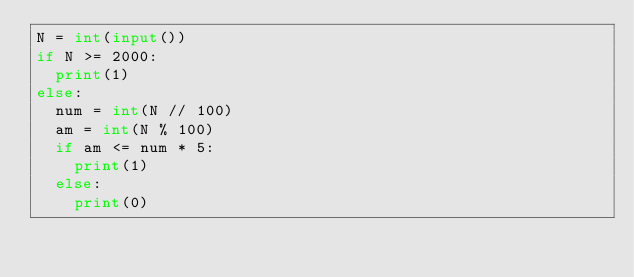Convert code to text. <code><loc_0><loc_0><loc_500><loc_500><_Python_>N = int(input())
if N >= 2000:
	print(1)
else:
	num = int(N // 100)
	am = int(N % 100)
	if am <= num * 5:
		print(1)
	else:
		print(0)</code> 